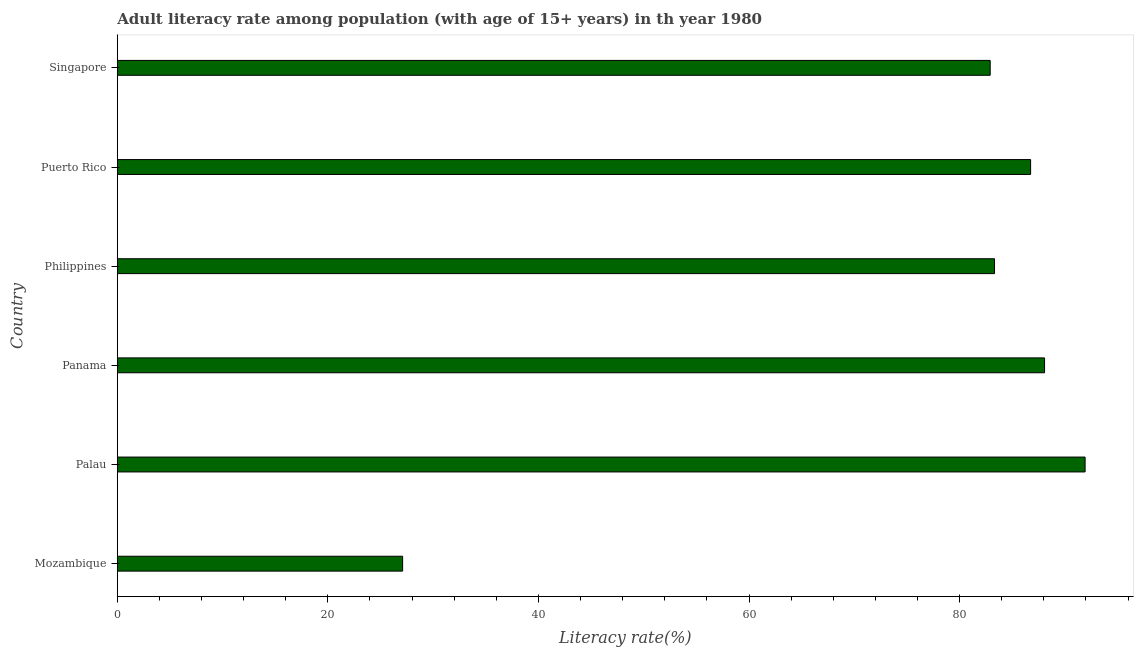Does the graph contain grids?
Give a very brief answer. No. What is the title of the graph?
Offer a terse response. Adult literacy rate among population (with age of 15+ years) in th year 1980. What is the label or title of the X-axis?
Your answer should be very brief. Literacy rate(%). What is the label or title of the Y-axis?
Offer a terse response. Country. What is the adult literacy rate in Mozambique?
Provide a succinct answer. 27.1. Across all countries, what is the maximum adult literacy rate?
Provide a succinct answer. 91.92. Across all countries, what is the minimum adult literacy rate?
Provide a short and direct response. 27.1. In which country was the adult literacy rate maximum?
Ensure brevity in your answer.  Palau. In which country was the adult literacy rate minimum?
Your answer should be very brief. Mozambique. What is the sum of the adult literacy rate?
Offer a terse response. 460.06. What is the difference between the adult literacy rate in Panama and Philippines?
Provide a succinct answer. 4.75. What is the average adult literacy rate per country?
Offer a very short reply. 76.68. What is the median adult literacy rate?
Offer a terse response. 85.03. What is the ratio of the adult literacy rate in Mozambique to that in Puerto Rico?
Keep it short and to the point. 0.31. What is the difference between the highest and the second highest adult literacy rate?
Your answer should be very brief. 3.85. Is the sum of the adult literacy rate in Palau and Puerto Rico greater than the maximum adult literacy rate across all countries?
Offer a very short reply. Yes. What is the difference between the highest and the lowest adult literacy rate?
Your response must be concise. 64.82. In how many countries, is the adult literacy rate greater than the average adult literacy rate taken over all countries?
Keep it short and to the point. 5. Are all the bars in the graph horizontal?
Your response must be concise. Yes. How many countries are there in the graph?
Offer a very short reply. 6. Are the values on the major ticks of X-axis written in scientific E-notation?
Your response must be concise. No. What is the Literacy rate(%) of Mozambique?
Give a very brief answer. 27.1. What is the Literacy rate(%) of Palau?
Your answer should be very brief. 91.92. What is the Literacy rate(%) in Panama?
Provide a short and direct response. 88.07. What is the Literacy rate(%) in Philippines?
Your answer should be compact. 83.32. What is the Literacy rate(%) of Puerto Rico?
Make the answer very short. 86.75. What is the Literacy rate(%) in Singapore?
Keep it short and to the point. 82.91. What is the difference between the Literacy rate(%) in Mozambique and Palau?
Your response must be concise. -64.82. What is the difference between the Literacy rate(%) in Mozambique and Panama?
Ensure brevity in your answer.  -60.97. What is the difference between the Literacy rate(%) in Mozambique and Philippines?
Make the answer very short. -56.22. What is the difference between the Literacy rate(%) in Mozambique and Puerto Rico?
Offer a terse response. -59.64. What is the difference between the Literacy rate(%) in Mozambique and Singapore?
Your response must be concise. -55.8. What is the difference between the Literacy rate(%) in Palau and Panama?
Your response must be concise. 3.85. What is the difference between the Literacy rate(%) in Palau and Philippines?
Your answer should be compact. 8.6. What is the difference between the Literacy rate(%) in Palau and Puerto Rico?
Offer a terse response. 5.18. What is the difference between the Literacy rate(%) in Palau and Singapore?
Provide a short and direct response. 9.02. What is the difference between the Literacy rate(%) in Panama and Philippines?
Ensure brevity in your answer.  4.75. What is the difference between the Literacy rate(%) in Panama and Puerto Rico?
Your response must be concise. 1.33. What is the difference between the Literacy rate(%) in Panama and Singapore?
Make the answer very short. 5.17. What is the difference between the Literacy rate(%) in Philippines and Puerto Rico?
Offer a very short reply. -3.43. What is the difference between the Literacy rate(%) in Philippines and Singapore?
Provide a succinct answer. 0.41. What is the difference between the Literacy rate(%) in Puerto Rico and Singapore?
Make the answer very short. 3.84. What is the ratio of the Literacy rate(%) in Mozambique to that in Palau?
Ensure brevity in your answer.  0.29. What is the ratio of the Literacy rate(%) in Mozambique to that in Panama?
Your answer should be very brief. 0.31. What is the ratio of the Literacy rate(%) in Mozambique to that in Philippines?
Offer a very short reply. 0.33. What is the ratio of the Literacy rate(%) in Mozambique to that in Puerto Rico?
Provide a short and direct response. 0.31. What is the ratio of the Literacy rate(%) in Mozambique to that in Singapore?
Offer a very short reply. 0.33. What is the ratio of the Literacy rate(%) in Palau to that in Panama?
Offer a very short reply. 1.04. What is the ratio of the Literacy rate(%) in Palau to that in Philippines?
Ensure brevity in your answer.  1.1. What is the ratio of the Literacy rate(%) in Palau to that in Puerto Rico?
Your answer should be compact. 1.06. What is the ratio of the Literacy rate(%) in Palau to that in Singapore?
Your response must be concise. 1.11. What is the ratio of the Literacy rate(%) in Panama to that in Philippines?
Your response must be concise. 1.06. What is the ratio of the Literacy rate(%) in Panama to that in Puerto Rico?
Provide a succinct answer. 1.01. What is the ratio of the Literacy rate(%) in Panama to that in Singapore?
Provide a short and direct response. 1.06. What is the ratio of the Literacy rate(%) in Puerto Rico to that in Singapore?
Offer a terse response. 1.05. 